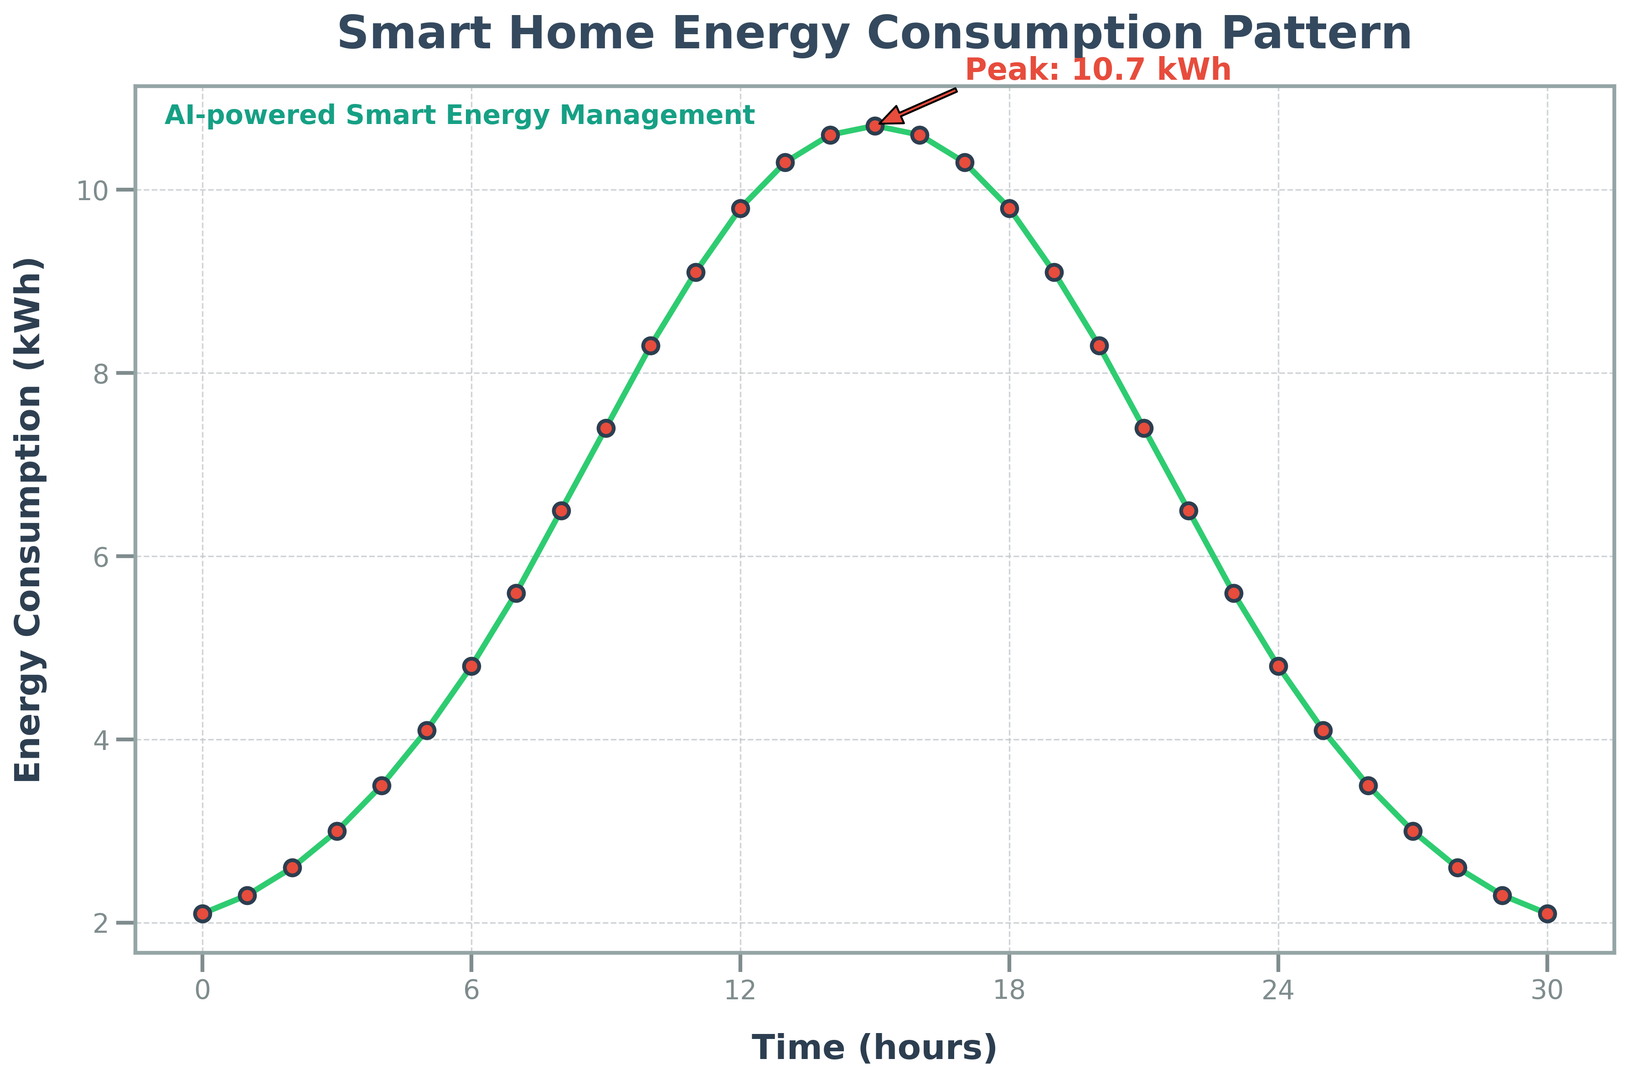What time does the energy consumption reach its peak? The peak energy consumption is visually annotated on the plot. The arrow points to the highest peak and marks the time.
Answer: 15 hours When is the energy consumption the lowest? The plot shows the energy consumption is lowest at the earliest and latest hours. Visually, it touches the bottom of the curve at 0 and 30 hours.
Answer: 0 and 30 hours What is the energy consumption at 12 hours? The y-axis value at 12 hours can be read directly from the plot where the marker hits the curve.
Answer: 9.8 kWh Between which two hours does the energy consumption increase the most? The steepest section of the curve indicates the highest increase in energy consumption. Visually check the slope of the line segments. It appears the sharpest climb is from 6 to 7 hours.
Answer: 6 to 7 hours How does the energy consumption change after reaching its peak? After the highest point at 15 hours, the curve declines symmetrically toward the end of the timeframe shown. The pattern indicates a decrease similar to the initial increase.
Answer: It decreases How can the peak energy consumption at 15 hours be quantitatively described? Look at the point where the annotation marks the peak. It explicitly states the energy consumption value.
Answer: 10.7 kWh What is the average energy consumption between 5 hours and 10 hours? Compute the average by first summing up energy values from 5 to 10 hours (4.1, 4.8, 5.6, 6.5, 7.4, 8.3). Sum = 36.7 kWh. Average = 36.7 kWh / 6.
Answer: 6.12 kWh Compare the energy consumption at 9 hours and 21 hours. Which is higher? Compare the y-axis values for 9 hours and 21 hours directly on the plot.
Answer: 9 hours What is the trend of energy consumption from 10 to 20 hours? Track the curve from 10 hours to 20 hours. It rises until the peak and then falls, indicating an increasing then decreasing trend.
Answer: Increases and then decreases What color is used for the grid lines on the plot? Visually inspect the grid lines; they are faint but visible on the background.
Answer: Gray 